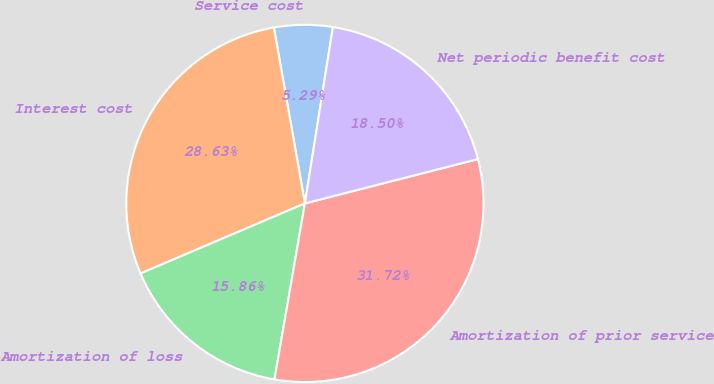Convert chart to OTSL. <chart><loc_0><loc_0><loc_500><loc_500><pie_chart><fcel>Service cost<fcel>Interest cost<fcel>Amortization of loss<fcel>Amortization of prior service<fcel>Net periodic benefit cost<nl><fcel>5.29%<fcel>28.63%<fcel>15.86%<fcel>31.72%<fcel>18.5%<nl></chart> 